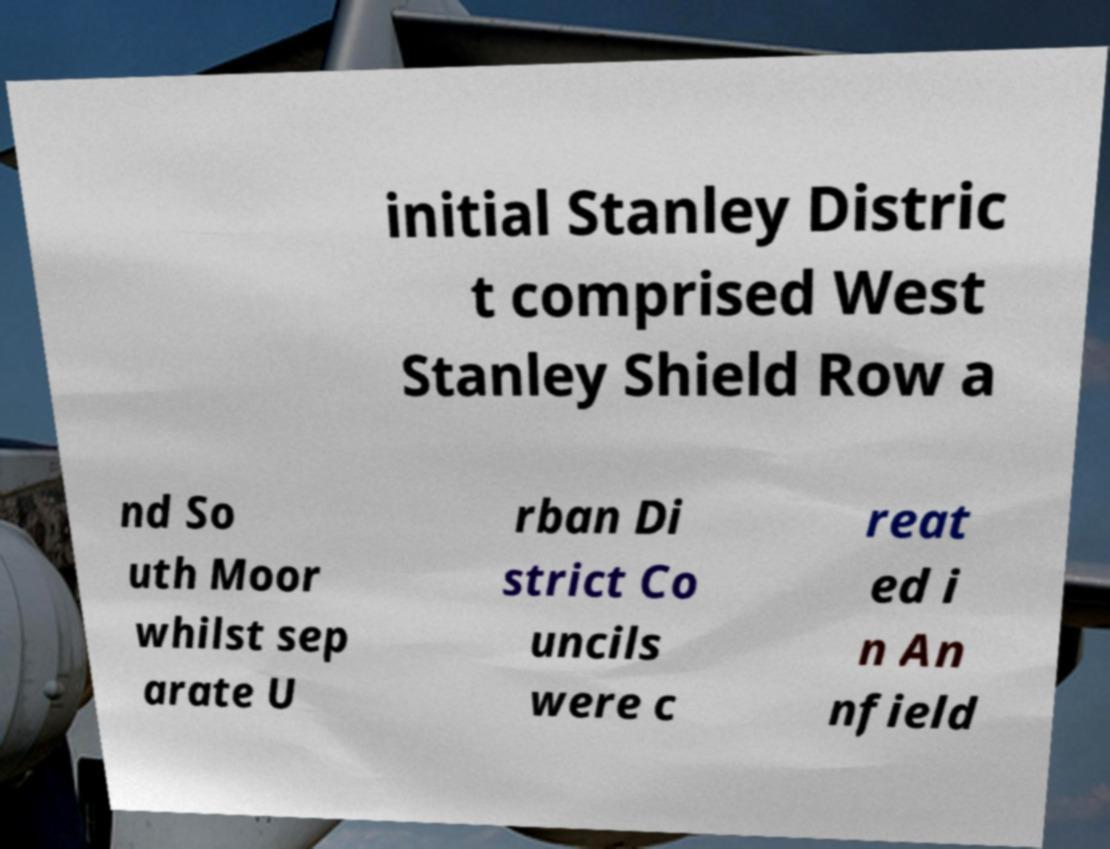Can you read and provide the text displayed in the image?This photo seems to have some interesting text. Can you extract and type it out for me? initial Stanley Distric t comprised West Stanley Shield Row a nd So uth Moor whilst sep arate U rban Di strict Co uncils were c reat ed i n An nfield 